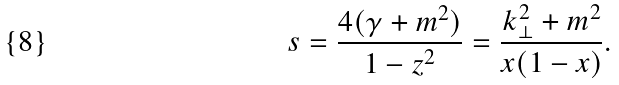<formula> <loc_0><loc_0><loc_500><loc_500>s = \frac { 4 ( \gamma + m ^ { 2 } ) } { 1 - z ^ { 2 } } = \frac { k _ { \perp } ^ { 2 } + m ^ { 2 } } { x ( 1 - x ) } .</formula> 